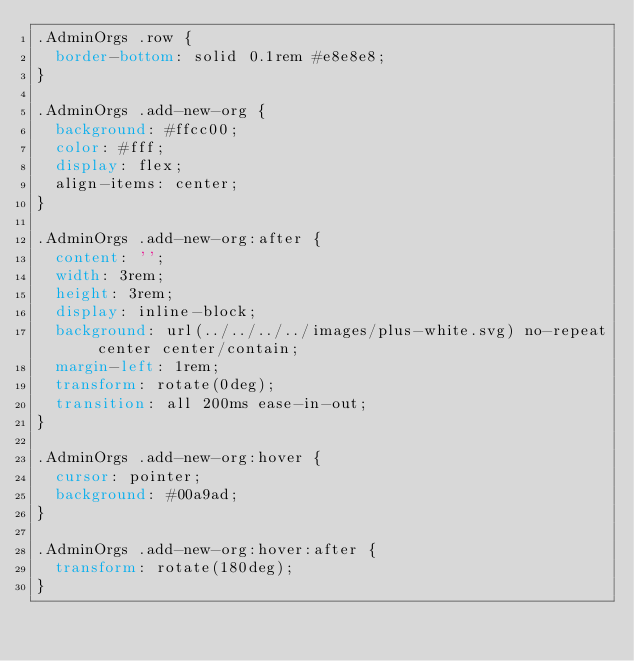Convert code to text. <code><loc_0><loc_0><loc_500><loc_500><_CSS_>.AdminOrgs .row {
  border-bottom: solid 0.1rem #e8e8e8;
}

.AdminOrgs .add-new-org {
  background: #ffcc00;
  color: #fff;
  display: flex;
  align-items: center;
}

.AdminOrgs .add-new-org:after {
  content: '';
  width: 3rem;
  height: 3rem;
  display: inline-block;
  background: url(../../../../images/plus-white.svg) no-repeat center center/contain;
  margin-left: 1rem;
  transform: rotate(0deg);
  transition: all 200ms ease-in-out;
}

.AdminOrgs .add-new-org:hover {
  cursor: pointer;
  background: #00a9ad;
}

.AdminOrgs .add-new-org:hover:after {
  transform: rotate(180deg);
}
</code> 